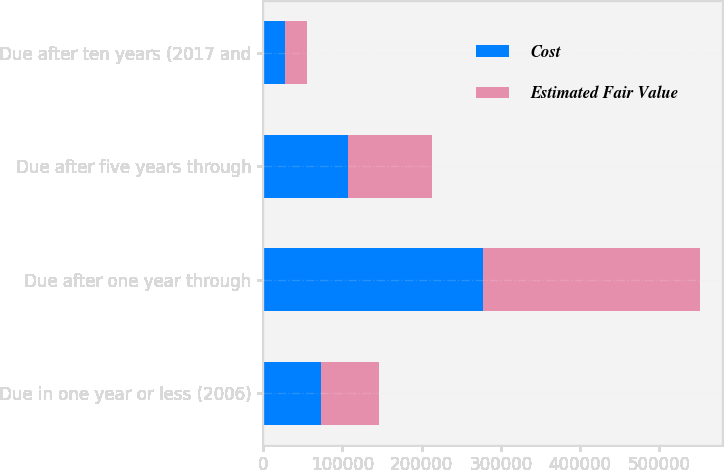Convert chart. <chart><loc_0><loc_0><loc_500><loc_500><stacked_bar_chart><ecel><fcel>Due in one year or less (2006)<fcel>Due after one year through<fcel>Due after five years through<fcel>Due after ten years (2017 and<nl><fcel>Cost<fcel>73398<fcel>277510<fcel>106917<fcel>27785<nl><fcel>Estimated Fair Value<fcel>73033<fcel>274143<fcel>106124<fcel>27576<nl></chart> 